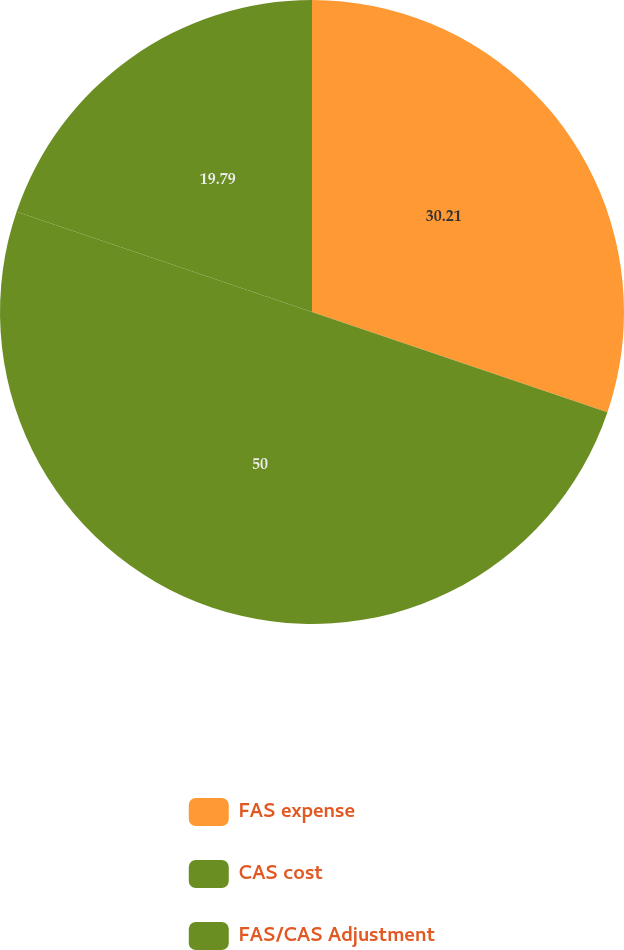Convert chart. <chart><loc_0><loc_0><loc_500><loc_500><pie_chart><fcel>FAS expense<fcel>CAS cost<fcel>FAS/CAS Adjustment<nl><fcel>30.21%<fcel>50.0%<fcel>19.79%<nl></chart> 